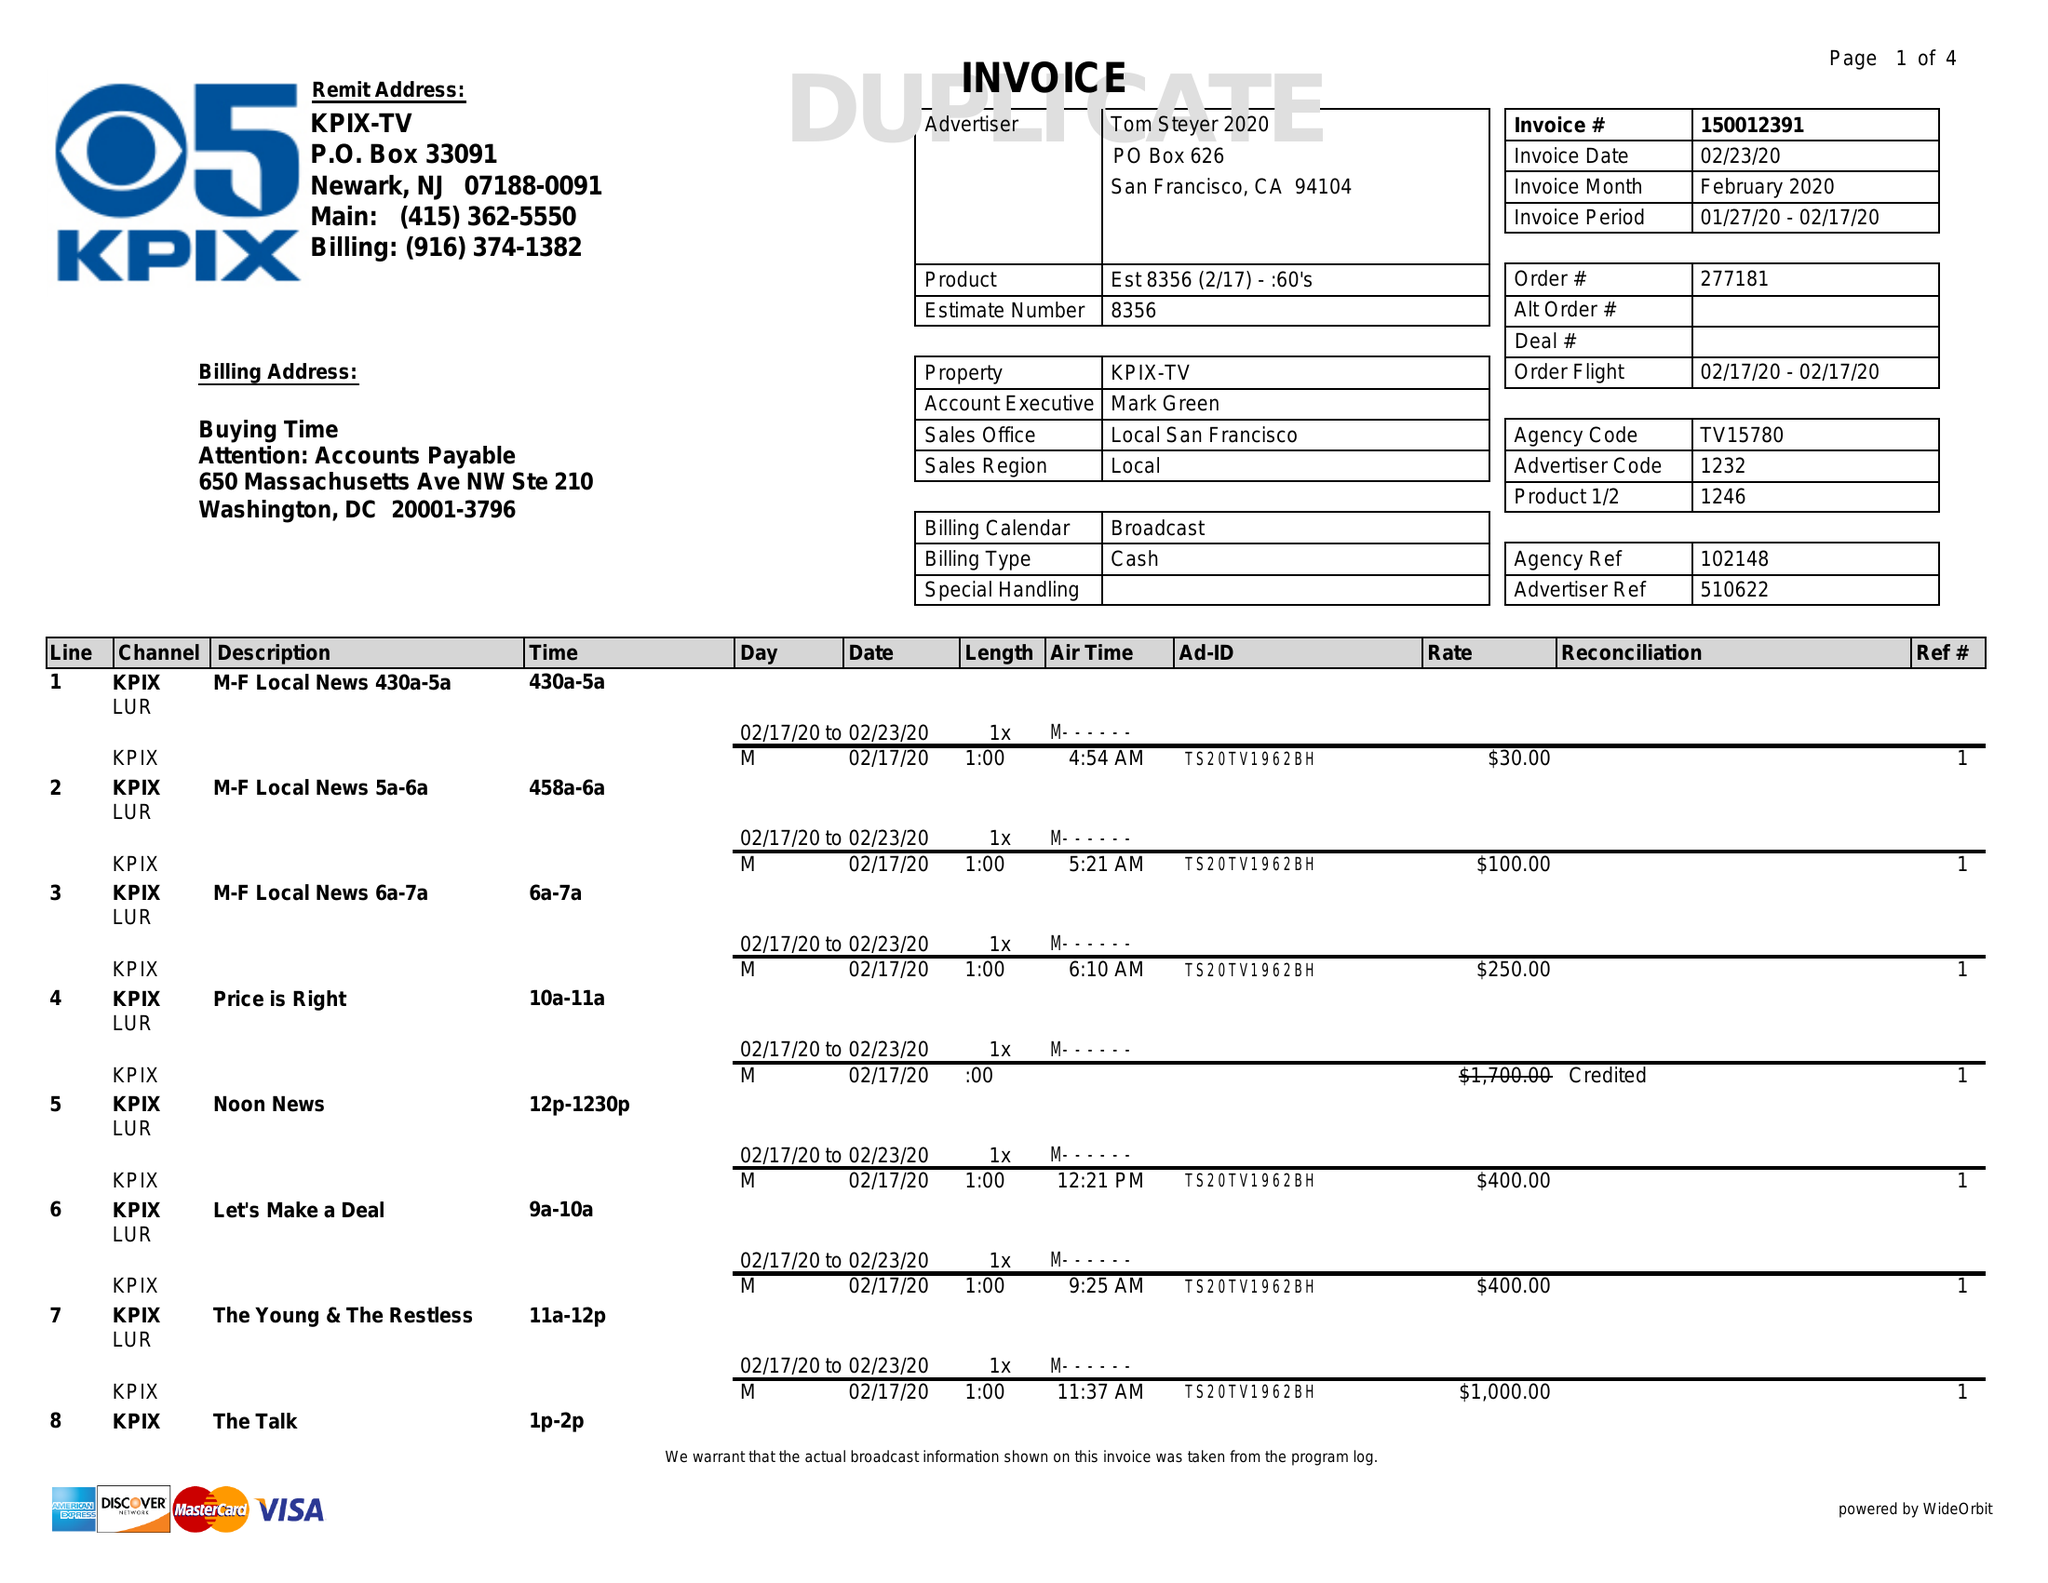What is the value for the flight_from?
Answer the question using a single word or phrase. 01/27/20 